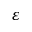Convert formula to latex. <formula><loc_0><loc_0><loc_500><loc_500>\varepsilon</formula> 